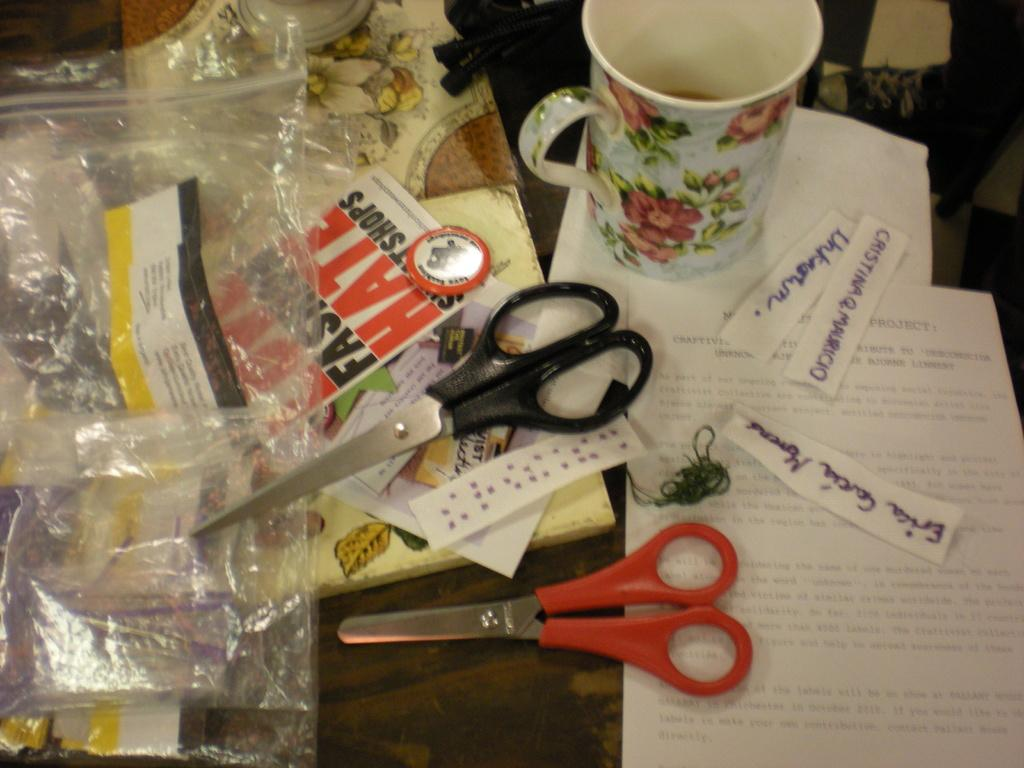What piece of furniture is present in the image? There is a table in the image. What objects can be seen on the table? There are scissors, a plastic cover, a mug, and papers on the table. What might be used for cutting in the image? Scissors can be used for cutting in the image. What might be used for holding a beverage in the image? A mug can be used for holding a beverage in the image. What type of worm can be seen crawling on the table in the image? There is no worm present in the image; it only features a table with scissors, a plastic cover, a mug, and papers. 